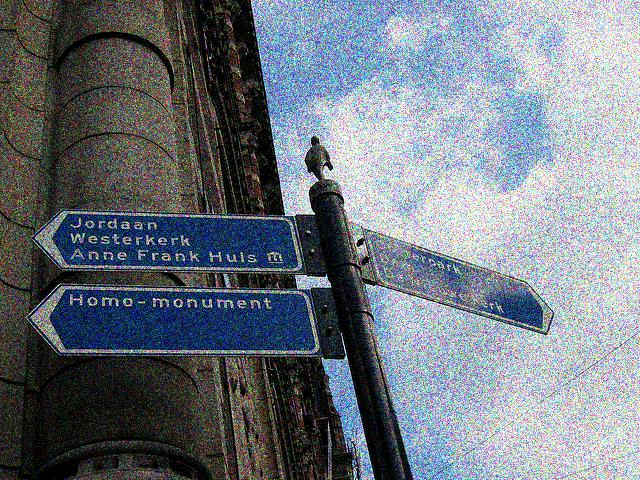What can you infer about the location shown in the image? Based on the language used on the signs (Dutch), it can be inferred that the image was likely taken in a Dutch-speaking country, possibly the Netherlands. The reference to 'Anne Frank Huis' suggests it might be Amsterdam, where the Anne Frank House is a well-known museum and historic site. The 'Homo-monument' sign also points to a landmark in Amsterdam that commemorates the gay men and lesbians who have been subjected to persecution because of their homosexuality. 